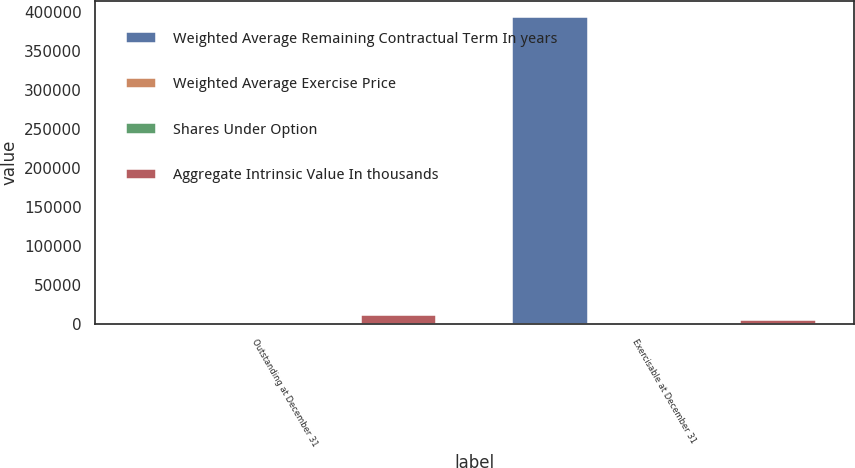<chart> <loc_0><loc_0><loc_500><loc_500><stacked_bar_chart><ecel><fcel>Outstanding at December 31<fcel>Exercisable at December 31<nl><fcel>Weighted Average Remaining Contractual Term In years<fcel>63.8<fcel>394565<nl><fcel>Weighted Average Exercise Price<fcel>62.09<fcel>63.8<nl><fcel>Shares Under Option<fcel>6.3<fcel>5.3<nl><fcel>Aggregate Intrinsic Value In thousands<fcel>12740<fcel>6067<nl></chart> 